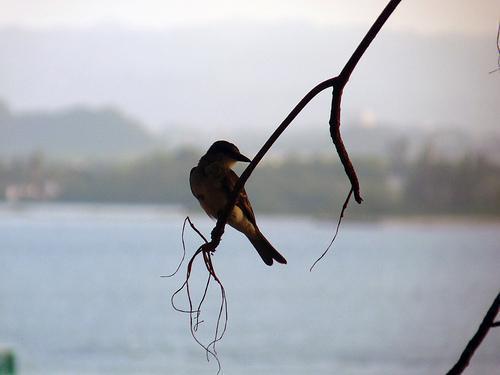How many animals are visible?
Give a very brief answer. 1. How many tree branches are in the photo?
Give a very brief answer. 2. How many birds are in the photo?
Give a very brief answer. 1. How many eggs are on the limb?
Give a very brief answer. 0. 